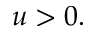<formula> <loc_0><loc_0><loc_500><loc_500>u > 0 .</formula> 